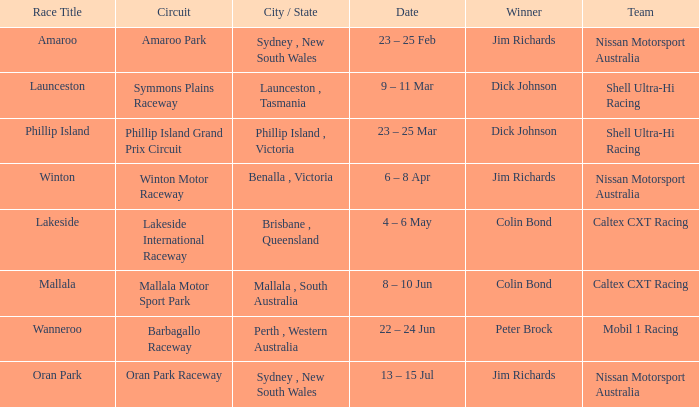Name the date for race title lakeside 4 – 6 May. 